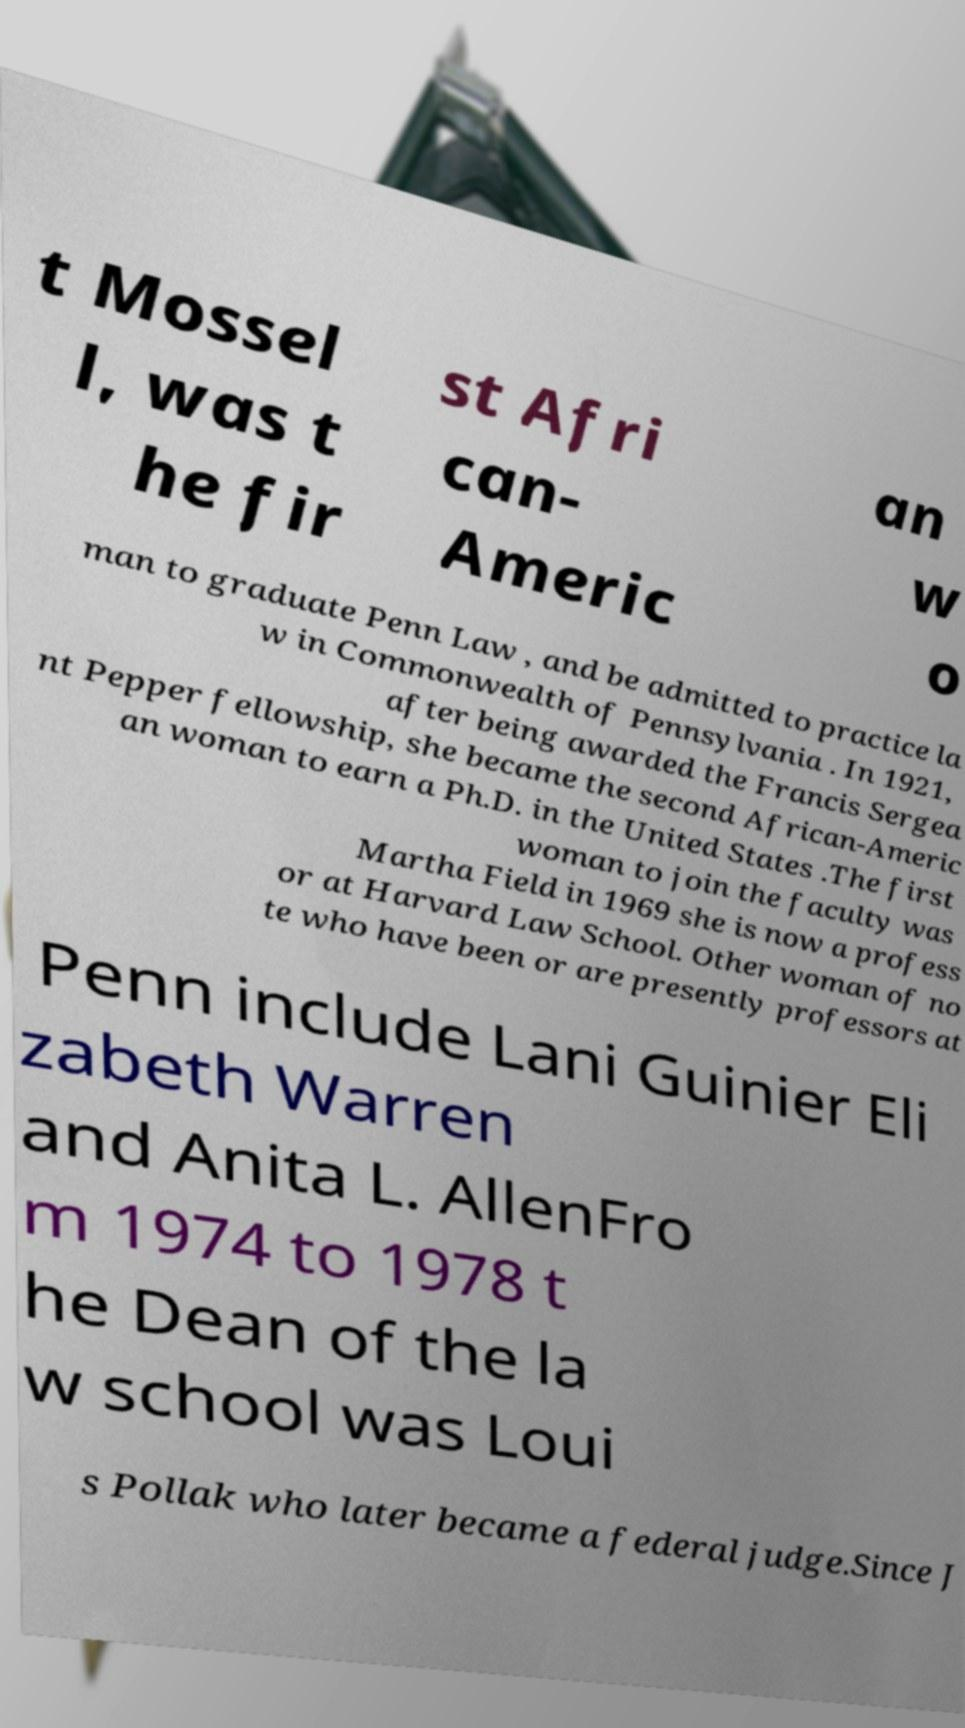Can you accurately transcribe the text from the provided image for me? t Mossel l, was t he fir st Afri can- Americ an w o man to graduate Penn Law , and be admitted to practice la w in Commonwealth of Pennsylvania . In 1921, after being awarded the Francis Sergea nt Pepper fellowship, she became the second African-Americ an woman to earn a Ph.D. in the United States .The first woman to join the faculty was Martha Field in 1969 she is now a profess or at Harvard Law School. Other woman of no te who have been or are presently professors at Penn include Lani Guinier Eli zabeth Warren and Anita L. AllenFro m 1974 to 1978 t he Dean of the la w school was Loui s Pollak who later became a federal judge.Since J 